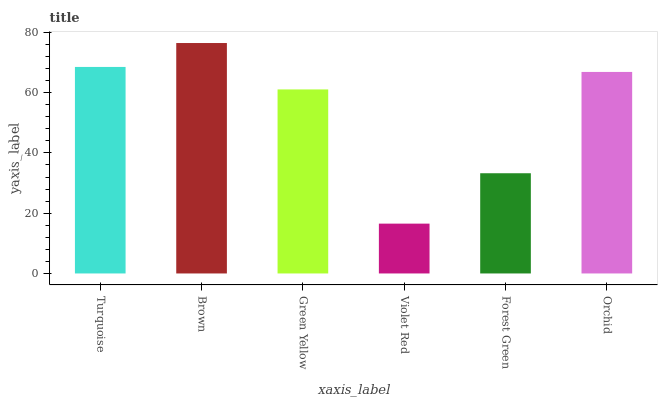Is Violet Red the minimum?
Answer yes or no. Yes. Is Brown the maximum?
Answer yes or no. Yes. Is Green Yellow the minimum?
Answer yes or no. No. Is Green Yellow the maximum?
Answer yes or no. No. Is Brown greater than Green Yellow?
Answer yes or no. Yes. Is Green Yellow less than Brown?
Answer yes or no. Yes. Is Green Yellow greater than Brown?
Answer yes or no. No. Is Brown less than Green Yellow?
Answer yes or no. No. Is Orchid the high median?
Answer yes or no. Yes. Is Green Yellow the low median?
Answer yes or no. Yes. Is Turquoise the high median?
Answer yes or no. No. Is Orchid the low median?
Answer yes or no. No. 